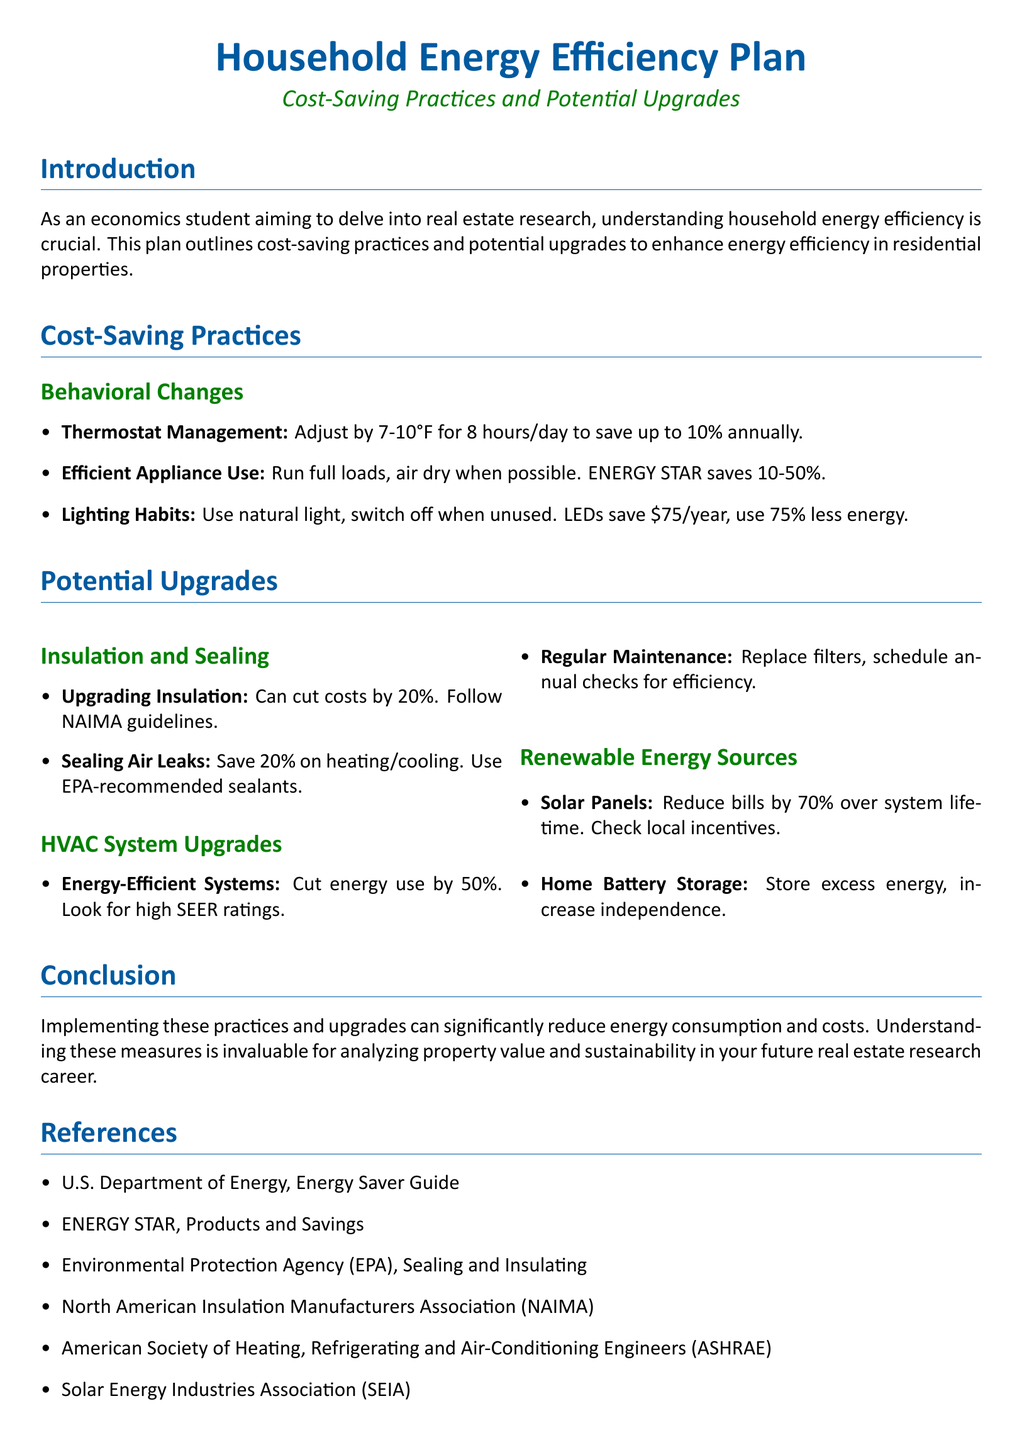What is the primary focus of the document? The document outlines cost-saving practices and potential upgrades to enhance energy efficiency in residential properties.
Answer: Household energy efficiency How much can thermostat management save annually? Adjusting the thermostat can save up to 10% annually.
Answer: 10% What is the estimated energy savings from using ENERGY STAR appliances? ENERGY STAR appliances can save between 10-50% energy.
Answer: 10-50% By upgrading insulation, what percentage of costs can be cut? Upgrading insulation can cut costs by 20%.
Answer: 20% What type of solar energy system can reduce bills by 70%? Solar panels can reduce bills by 70% over their system lifetime.
Answer: Solar panels What is recommended for sealing air leaks? The document suggests using EPA-recommended sealants for sealing air leaks.
Answer: EPA-recommended sealants How much can energy-efficient HVAC systems cut energy use? Energy-efficient systems can cut energy use by 50%.
Answer: 50% What should be scheduled annually for HVAC systems? Annual checks should be scheduled for HVAC systems.
Answer: Annual checks What is one potential benefit of home battery storage? Home battery storage can increase energy independence.
Answer: Increase independence 